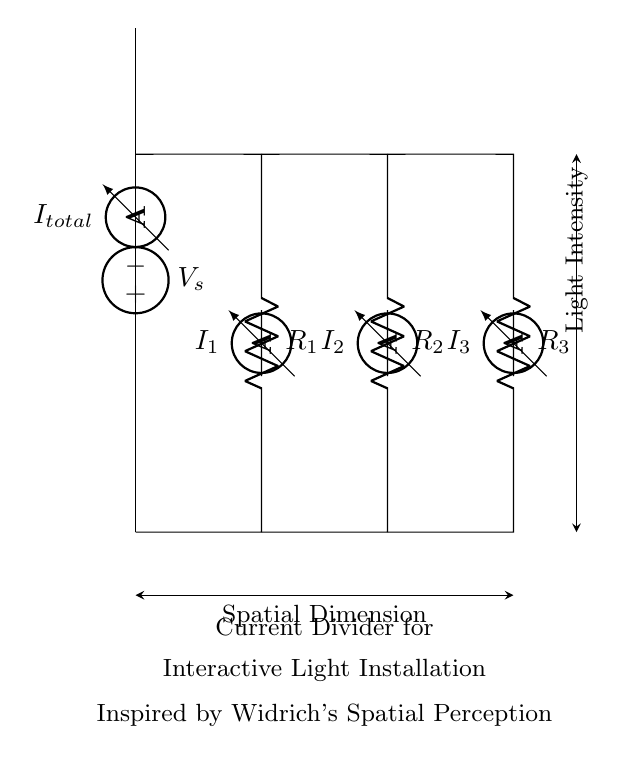What is the total current in the circuit? The total current, denoted as I_total, is represented by the ammeter at the top of the circuit. It is the sum of the currents passing through each resistor, R1, R2, and R3.
Answer: I_total What are the resistances in this circuit? The circuit displays three resistors, labeled R1, R2, and R3. Each resistor value is shown next to its symbol, representing the resistance contributing to the current divider function.
Answer: R1, R2, R3 How many ammeters are present in this circuit? The circuit shows three ammeters, each labeled I1, I2, and I3, measuring the current through R1, R2, and R3 respectively.
Answer: Three Which element divides the current in the circuit? The resistors R1, R2, and R3 share the total current I_total. The division occurs according to the resistance values, which influence how the total current is distributed among them.
Answer: Resistors What is the purpose of the voltage source in this circuit? The voltage source, represented as V_s, supplies the necessary electrical energy for the circuit. It establishes a potential difference that drives the total current through the resistors, enabling the current division effect.
Answer: Supply voltage How does the total current split among the resistors? The total current I_total flows through the voltage source and divides among the parallel resistors based on their resistance values, following Ohm's Law. The relationship is quantitatively described by the current divider formula, which states that the current through a resistor is inversely proportional to its resistance compared to the total resistance in the parallel configuration.
Answer: Based on resistance values 